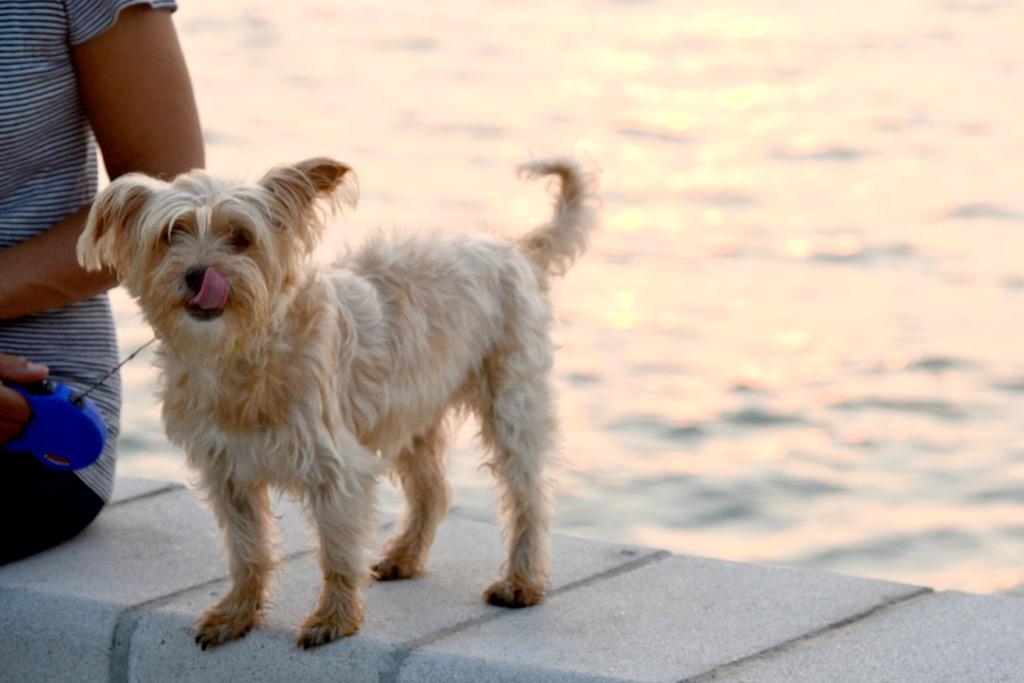What is the dog doing in the image? The dog is standing on a brick wall in the image. What can be seen on the left side of the image? There is a person on the left side of the image. What is the person holding in the image? The person is holding something in the image. How is the dog connected to the wall or the person? A rope is attached to the dog in the image. What is visible in the background of the image? Water is visible in the background of the image. What type of knowledge can be gained from the creature in the image? There is no creature present in the image, so no knowledge can be gained from it. How many pins are visible in the image? There are no pins visible in the image. 